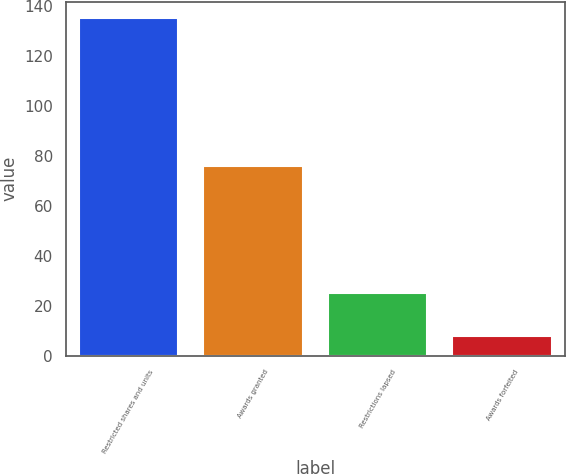Convert chart. <chart><loc_0><loc_0><loc_500><loc_500><bar_chart><fcel>Restricted shares and units<fcel>Awards granted<fcel>Restrictions lapsed<fcel>Awards forfeited<nl><fcel>135<fcel>76<fcel>25<fcel>8<nl></chart> 